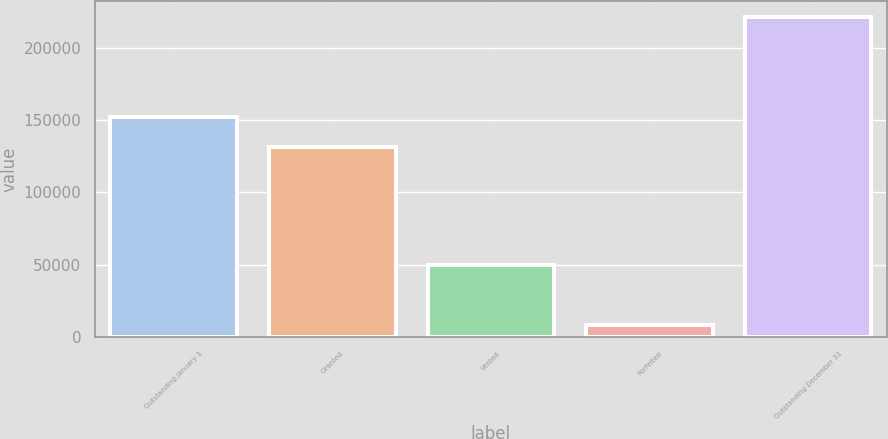Convert chart. <chart><loc_0><loc_0><loc_500><loc_500><bar_chart><fcel>Outstanding January 1<fcel>Granted<fcel>Vested<fcel>Forfeited<fcel>Outstanding December 31<nl><fcel>152461<fcel>131145<fcel>49822<fcel>8102<fcel>221265<nl></chart> 